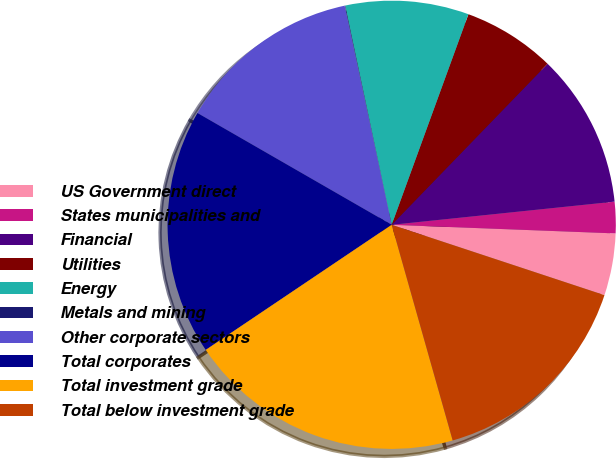Convert chart to OTSL. <chart><loc_0><loc_0><loc_500><loc_500><pie_chart><fcel>US Government direct<fcel>States municipalities and<fcel>Financial<fcel>Utilities<fcel>Energy<fcel>Metals and mining<fcel>Other corporate sectors<fcel>Total corporates<fcel>Total investment grade<fcel>Total below investment grade<nl><fcel>4.47%<fcel>2.26%<fcel>11.11%<fcel>6.68%<fcel>8.89%<fcel>0.04%<fcel>13.32%<fcel>17.74%<fcel>19.96%<fcel>15.53%<nl></chart> 